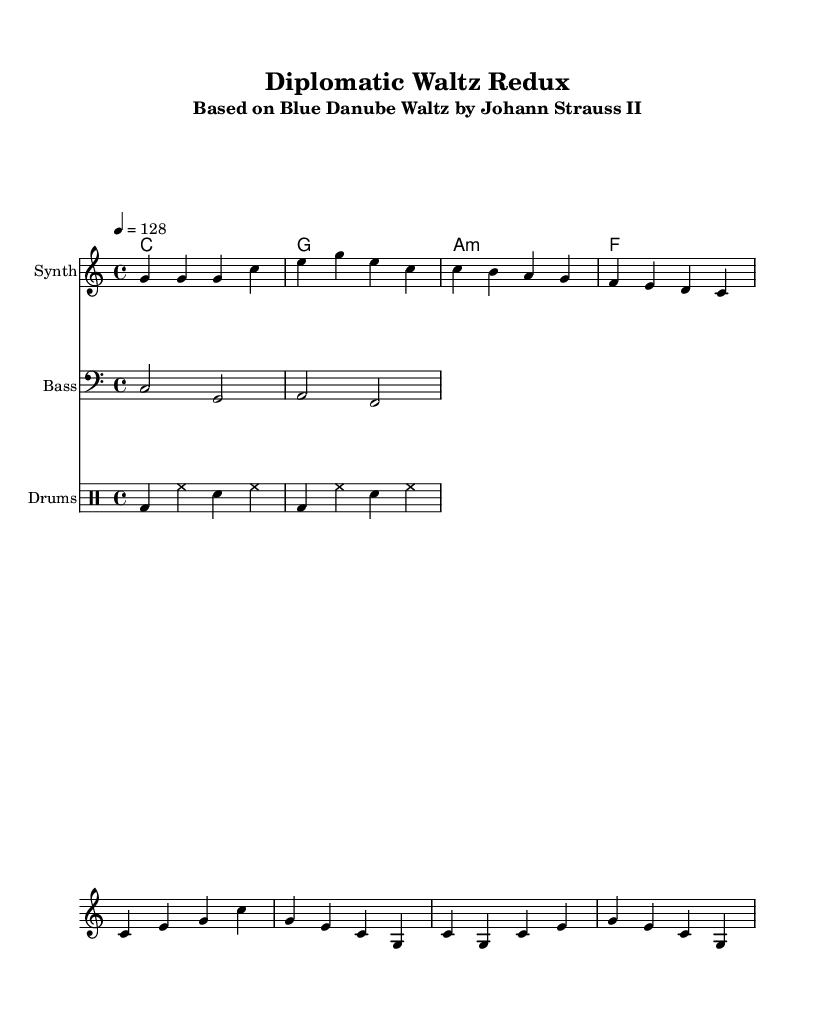What is the key signature of this music? The key signature indicates C major, which has no sharps or flats. This can be confirmed by observing the absence of any sharp or flat symbols on the staff.
Answer: C major What is the time signature of this piece? The time signature is 4/4, which is commonly visualized at the beginning of the music as a fraction. This means there are four beats in a measure, and the quarter note gets one beat.
Answer: 4/4 What is the tempo marking for this composition? The tempo marking indicates a speed of 128 beats per minute. This is noted at the beginning of the sheet music as a tempo indication.
Answer: 128 How many measures are in the melody section? Counting the measures in the melody part shows there are 8 measures. Each measure is separated by vertical lines on the staff.
Answer: 8 What type of composition is this? The composition is a remix of a classical waltz, specifically based on the Blue Danube Waltz by Johann Strauss II. This is stated in the subtitle of the header.
Answer: Remix Which instruments are used in this score? The score includes a synthesizer, bass, and drums, which can be identified by the different staff labels provided at the start of each instrument's section.
Answer: Synth, Bass, Drums What is the chord used in the first measure? The chord indicated in the first measure is a C major chord, which can be identified by the symbols and notes aligned vertically in the chord names section.
Answer: C 